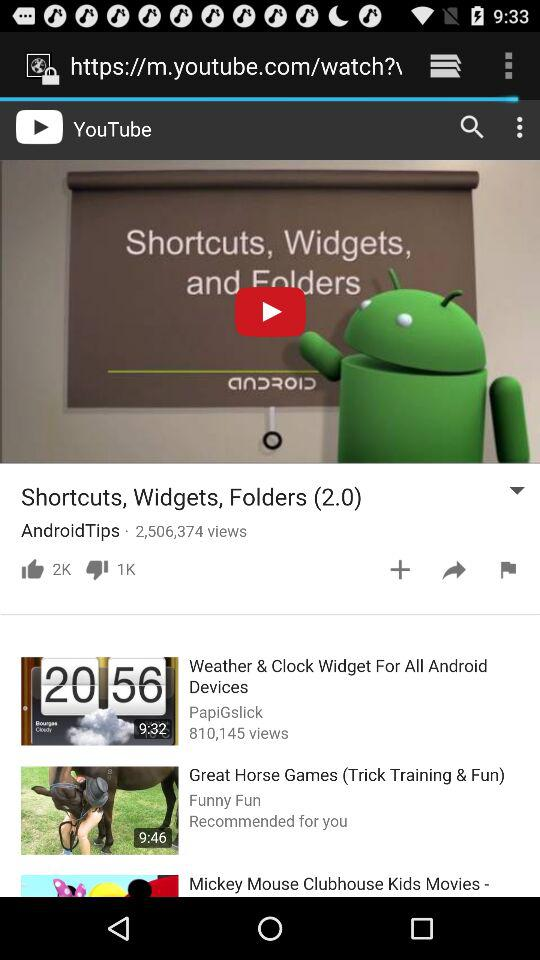How many dislikes are there of the video? There are 1K dislikes. 